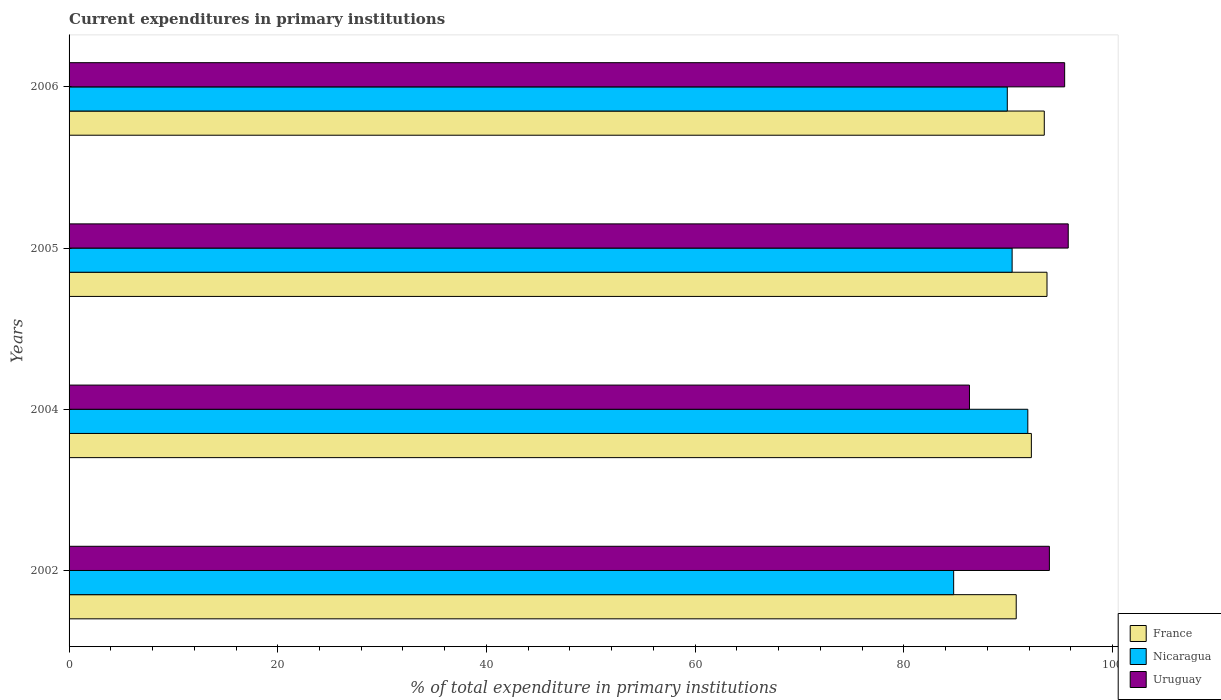Are the number of bars on each tick of the Y-axis equal?
Provide a short and direct response. Yes. How many bars are there on the 2nd tick from the top?
Your answer should be very brief. 3. What is the label of the 4th group of bars from the top?
Keep it short and to the point. 2002. What is the current expenditures in primary institutions in Uruguay in 2005?
Offer a very short reply. 95.76. Across all years, what is the maximum current expenditures in primary institutions in Uruguay?
Make the answer very short. 95.76. Across all years, what is the minimum current expenditures in primary institutions in France?
Give a very brief answer. 90.77. In which year was the current expenditures in primary institutions in France maximum?
Provide a short and direct response. 2005. What is the total current expenditures in primary institutions in Nicaragua in the graph?
Your answer should be compact. 356.96. What is the difference between the current expenditures in primary institutions in Nicaragua in 2004 and that in 2006?
Keep it short and to the point. 1.97. What is the difference between the current expenditures in primary institutions in Uruguay in 2005 and the current expenditures in primary institutions in France in 2002?
Keep it short and to the point. 4.99. What is the average current expenditures in primary institutions in Nicaragua per year?
Offer a terse response. 89.24. In the year 2006, what is the difference between the current expenditures in primary institutions in Nicaragua and current expenditures in primary institutions in France?
Your answer should be very brief. -3.54. In how many years, is the current expenditures in primary institutions in France greater than 36 %?
Offer a very short reply. 4. What is the ratio of the current expenditures in primary institutions in Nicaragua in 2004 to that in 2005?
Offer a terse response. 1.02. Is the difference between the current expenditures in primary institutions in Nicaragua in 2002 and 2006 greater than the difference between the current expenditures in primary institutions in France in 2002 and 2006?
Offer a terse response. No. What is the difference between the highest and the second highest current expenditures in primary institutions in Uruguay?
Your response must be concise. 0.34. What is the difference between the highest and the lowest current expenditures in primary institutions in France?
Offer a terse response. 2.95. What does the 3rd bar from the top in 2005 represents?
Your response must be concise. France. What does the 3rd bar from the bottom in 2004 represents?
Give a very brief answer. Uruguay. How many years are there in the graph?
Make the answer very short. 4. What is the difference between two consecutive major ticks on the X-axis?
Provide a succinct answer. 20. Are the values on the major ticks of X-axis written in scientific E-notation?
Keep it short and to the point. No. Does the graph contain grids?
Your answer should be very brief. No. How many legend labels are there?
Provide a short and direct response. 3. How are the legend labels stacked?
Make the answer very short. Vertical. What is the title of the graph?
Keep it short and to the point. Current expenditures in primary institutions. Does "Macedonia" appear as one of the legend labels in the graph?
Offer a very short reply. No. What is the label or title of the X-axis?
Offer a terse response. % of total expenditure in primary institutions. What is the label or title of the Y-axis?
Your answer should be very brief. Years. What is the % of total expenditure in primary institutions of France in 2002?
Give a very brief answer. 90.77. What is the % of total expenditure in primary institutions of Nicaragua in 2002?
Offer a terse response. 84.78. What is the % of total expenditure in primary institutions of Uruguay in 2002?
Your answer should be compact. 93.95. What is the % of total expenditure in primary institutions of France in 2004?
Ensure brevity in your answer.  92.22. What is the % of total expenditure in primary institutions of Nicaragua in 2004?
Your answer should be compact. 91.89. What is the % of total expenditure in primary institutions of Uruguay in 2004?
Provide a short and direct response. 86.29. What is the % of total expenditure in primary institutions in France in 2005?
Offer a terse response. 93.72. What is the % of total expenditure in primary institutions of Nicaragua in 2005?
Give a very brief answer. 90.38. What is the % of total expenditure in primary institutions in Uruguay in 2005?
Offer a terse response. 95.76. What is the % of total expenditure in primary institutions in France in 2006?
Keep it short and to the point. 93.46. What is the % of total expenditure in primary institutions in Nicaragua in 2006?
Your answer should be compact. 89.92. What is the % of total expenditure in primary institutions of Uruguay in 2006?
Provide a succinct answer. 95.42. Across all years, what is the maximum % of total expenditure in primary institutions in France?
Provide a succinct answer. 93.72. Across all years, what is the maximum % of total expenditure in primary institutions in Nicaragua?
Make the answer very short. 91.89. Across all years, what is the maximum % of total expenditure in primary institutions in Uruguay?
Your answer should be very brief. 95.76. Across all years, what is the minimum % of total expenditure in primary institutions of France?
Your response must be concise. 90.77. Across all years, what is the minimum % of total expenditure in primary institutions of Nicaragua?
Your response must be concise. 84.78. Across all years, what is the minimum % of total expenditure in primary institutions in Uruguay?
Make the answer very short. 86.29. What is the total % of total expenditure in primary institutions of France in the graph?
Offer a very short reply. 370.19. What is the total % of total expenditure in primary institutions in Nicaragua in the graph?
Make the answer very short. 356.96. What is the total % of total expenditure in primary institutions of Uruguay in the graph?
Provide a short and direct response. 371.42. What is the difference between the % of total expenditure in primary institutions in France in 2002 and that in 2004?
Give a very brief answer. -1.45. What is the difference between the % of total expenditure in primary institutions of Nicaragua in 2002 and that in 2004?
Provide a short and direct response. -7.11. What is the difference between the % of total expenditure in primary institutions of Uruguay in 2002 and that in 2004?
Your response must be concise. 7.66. What is the difference between the % of total expenditure in primary institutions in France in 2002 and that in 2005?
Provide a short and direct response. -2.95. What is the difference between the % of total expenditure in primary institutions in Nicaragua in 2002 and that in 2005?
Your response must be concise. -5.6. What is the difference between the % of total expenditure in primary institutions in Uruguay in 2002 and that in 2005?
Your response must be concise. -1.81. What is the difference between the % of total expenditure in primary institutions of France in 2002 and that in 2006?
Your answer should be compact. -2.69. What is the difference between the % of total expenditure in primary institutions of Nicaragua in 2002 and that in 2006?
Keep it short and to the point. -5.14. What is the difference between the % of total expenditure in primary institutions of Uruguay in 2002 and that in 2006?
Offer a terse response. -1.46. What is the difference between the % of total expenditure in primary institutions in France in 2004 and that in 2005?
Give a very brief answer. -1.5. What is the difference between the % of total expenditure in primary institutions of Nicaragua in 2004 and that in 2005?
Provide a short and direct response. 1.5. What is the difference between the % of total expenditure in primary institutions of Uruguay in 2004 and that in 2005?
Your answer should be compact. -9.47. What is the difference between the % of total expenditure in primary institutions in France in 2004 and that in 2006?
Your answer should be very brief. -1.24. What is the difference between the % of total expenditure in primary institutions in Nicaragua in 2004 and that in 2006?
Ensure brevity in your answer.  1.97. What is the difference between the % of total expenditure in primary institutions in Uruguay in 2004 and that in 2006?
Offer a very short reply. -9.12. What is the difference between the % of total expenditure in primary institutions in France in 2005 and that in 2006?
Make the answer very short. 0.26. What is the difference between the % of total expenditure in primary institutions in Nicaragua in 2005 and that in 2006?
Provide a short and direct response. 0.46. What is the difference between the % of total expenditure in primary institutions of Uruguay in 2005 and that in 2006?
Keep it short and to the point. 0.34. What is the difference between the % of total expenditure in primary institutions of France in 2002 and the % of total expenditure in primary institutions of Nicaragua in 2004?
Your answer should be very brief. -1.11. What is the difference between the % of total expenditure in primary institutions in France in 2002 and the % of total expenditure in primary institutions in Uruguay in 2004?
Offer a very short reply. 4.48. What is the difference between the % of total expenditure in primary institutions in Nicaragua in 2002 and the % of total expenditure in primary institutions in Uruguay in 2004?
Your answer should be very brief. -1.52. What is the difference between the % of total expenditure in primary institutions of France in 2002 and the % of total expenditure in primary institutions of Nicaragua in 2005?
Offer a terse response. 0.39. What is the difference between the % of total expenditure in primary institutions of France in 2002 and the % of total expenditure in primary institutions of Uruguay in 2005?
Your answer should be compact. -4.99. What is the difference between the % of total expenditure in primary institutions of Nicaragua in 2002 and the % of total expenditure in primary institutions of Uruguay in 2005?
Your answer should be compact. -10.98. What is the difference between the % of total expenditure in primary institutions in France in 2002 and the % of total expenditure in primary institutions in Nicaragua in 2006?
Provide a succinct answer. 0.86. What is the difference between the % of total expenditure in primary institutions of France in 2002 and the % of total expenditure in primary institutions of Uruguay in 2006?
Your answer should be compact. -4.64. What is the difference between the % of total expenditure in primary institutions in Nicaragua in 2002 and the % of total expenditure in primary institutions in Uruguay in 2006?
Make the answer very short. -10.64. What is the difference between the % of total expenditure in primary institutions in France in 2004 and the % of total expenditure in primary institutions in Nicaragua in 2005?
Make the answer very short. 1.84. What is the difference between the % of total expenditure in primary institutions of France in 2004 and the % of total expenditure in primary institutions of Uruguay in 2005?
Make the answer very short. -3.53. What is the difference between the % of total expenditure in primary institutions in Nicaragua in 2004 and the % of total expenditure in primary institutions in Uruguay in 2005?
Your response must be concise. -3.87. What is the difference between the % of total expenditure in primary institutions of France in 2004 and the % of total expenditure in primary institutions of Nicaragua in 2006?
Ensure brevity in your answer.  2.31. What is the difference between the % of total expenditure in primary institutions of France in 2004 and the % of total expenditure in primary institutions of Uruguay in 2006?
Offer a terse response. -3.19. What is the difference between the % of total expenditure in primary institutions in Nicaragua in 2004 and the % of total expenditure in primary institutions in Uruguay in 2006?
Your answer should be very brief. -3.53. What is the difference between the % of total expenditure in primary institutions of France in 2005 and the % of total expenditure in primary institutions of Nicaragua in 2006?
Make the answer very short. 3.81. What is the difference between the % of total expenditure in primary institutions in France in 2005 and the % of total expenditure in primary institutions in Uruguay in 2006?
Provide a short and direct response. -1.69. What is the difference between the % of total expenditure in primary institutions of Nicaragua in 2005 and the % of total expenditure in primary institutions of Uruguay in 2006?
Provide a succinct answer. -5.03. What is the average % of total expenditure in primary institutions of France per year?
Keep it short and to the point. 92.55. What is the average % of total expenditure in primary institutions of Nicaragua per year?
Ensure brevity in your answer.  89.24. What is the average % of total expenditure in primary institutions in Uruguay per year?
Provide a succinct answer. 92.86. In the year 2002, what is the difference between the % of total expenditure in primary institutions in France and % of total expenditure in primary institutions in Nicaragua?
Provide a short and direct response. 6. In the year 2002, what is the difference between the % of total expenditure in primary institutions in France and % of total expenditure in primary institutions in Uruguay?
Keep it short and to the point. -3.18. In the year 2002, what is the difference between the % of total expenditure in primary institutions in Nicaragua and % of total expenditure in primary institutions in Uruguay?
Your response must be concise. -9.17. In the year 2004, what is the difference between the % of total expenditure in primary institutions of France and % of total expenditure in primary institutions of Nicaragua?
Offer a terse response. 0.34. In the year 2004, what is the difference between the % of total expenditure in primary institutions in France and % of total expenditure in primary institutions in Uruguay?
Provide a short and direct response. 5.93. In the year 2004, what is the difference between the % of total expenditure in primary institutions of Nicaragua and % of total expenditure in primary institutions of Uruguay?
Make the answer very short. 5.59. In the year 2005, what is the difference between the % of total expenditure in primary institutions in France and % of total expenditure in primary institutions in Nicaragua?
Provide a short and direct response. 3.34. In the year 2005, what is the difference between the % of total expenditure in primary institutions in France and % of total expenditure in primary institutions in Uruguay?
Your response must be concise. -2.04. In the year 2005, what is the difference between the % of total expenditure in primary institutions of Nicaragua and % of total expenditure in primary institutions of Uruguay?
Ensure brevity in your answer.  -5.38. In the year 2006, what is the difference between the % of total expenditure in primary institutions in France and % of total expenditure in primary institutions in Nicaragua?
Provide a short and direct response. 3.54. In the year 2006, what is the difference between the % of total expenditure in primary institutions of France and % of total expenditure in primary institutions of Uruguay?
Offer a terse response. -1.95. In the year 2006, what is the difference between the % of total expenditure in primary institutions of Nicaragua and % of total expenditure in primary institutions of Uruguay?
Offer a very short reply. -5.5. What is the ratio of the % of total expenditure in primary institutions of France in 2002 to that in 2004?
Ensure brevity in your answer.  0.98. What is the ratio of the % of total expenditure in primary institutions in Nicaragua in 2002 to that in 2004?
Provide a short and direct response. 0.92. What is the ratio of the % of total expenditure in primary institutions in Uruguay in 2002 to that in 2004?
Offer a terse response. 1.09. What is the ratio of the % of total expenditure in primary institutions of France in 2002 to that in 2005?
Ensure brevity in your answer.  0.97. What is the ratio of the % of total expenditure in primary institutions in Nicaragua in 2002 to that in 2005?
Give a very brief answer. 0.94. What is the ratio of the % of total expenditure in primary institutions in Uruguay in 2002 to that in 2005?
Offer a terse response. 0.98. What is the ratio of the % of total expenditure in primary institutions in France in 2002 to that in 2006?
Give a very brief answer. 0.97. What is the ratio of the % of total expenditure in primary institutions of Nicaragua in 2002 to that in 2006?
Your answer should be very brief. 0.94. What is the ratio of the % of total expenditure in primary institutions of Uruguay in 2002 to that in 2006?
Provide a short and direct response. 0.98. What is the ratio of the % of total expenditure in primary institutions in Nicaragua in 2004 to that in 2005?
Keep it short and to the point. 1.02. What is the ratio of the % of total expenditure in primary institutions in Uruguay in 2004 to that in 2005?
Offer a terse response. 0.9. What is the ratio of the % of total expenditure in primary institutions of France in 2004 to that in 2006?
Give a very brief answer. 0.99. What is the ratio of the % of total expenditure in primary institutions of Nicaragua in 2004 to that in 2006?
Provide a succinct answer. 1.02. What is the ratio of the % of total expenditure in primary institutions in Uruguay in 2004 to that in 2006?
Your answer should be compact. 0.9. What is the ratio of the % of total expenditure in primary institutions in Nicaragua in 2005 to that in 2006?
Provide a succinct answer. 1.01. What is the ratio of the % of total expenditure in primary institutions of Uruguay in 2005 to that in 2006?
Your response must be concise. 1. What is the difference between the highest and the second highest % of total expenditure in primary institutions of France?
Give a very brief answer. 0.26. What is the difference between the highest and the second highest % of total expenditure in primary institutions of Nicaragua?
Offer a very short reply. 1.5. What is the difference between the highest and the second highest % of total expenditure in primary institutions of Uruguay?
Your answer should be compact. 0.34. What is the difference between the highest and the lowest % of total expenditure in primary institutions of France?
Provide a succinct answer. 2.95. What is the difference between the highest and the lowest % of total expenditure in primary institutions in Nicaragua?
Make the answer very short. 7.11. What is the difference between the highest and the lowest % of total expenditure in primary institutions in Uruguay?
Ensure brevity in your answer.  9.47. 